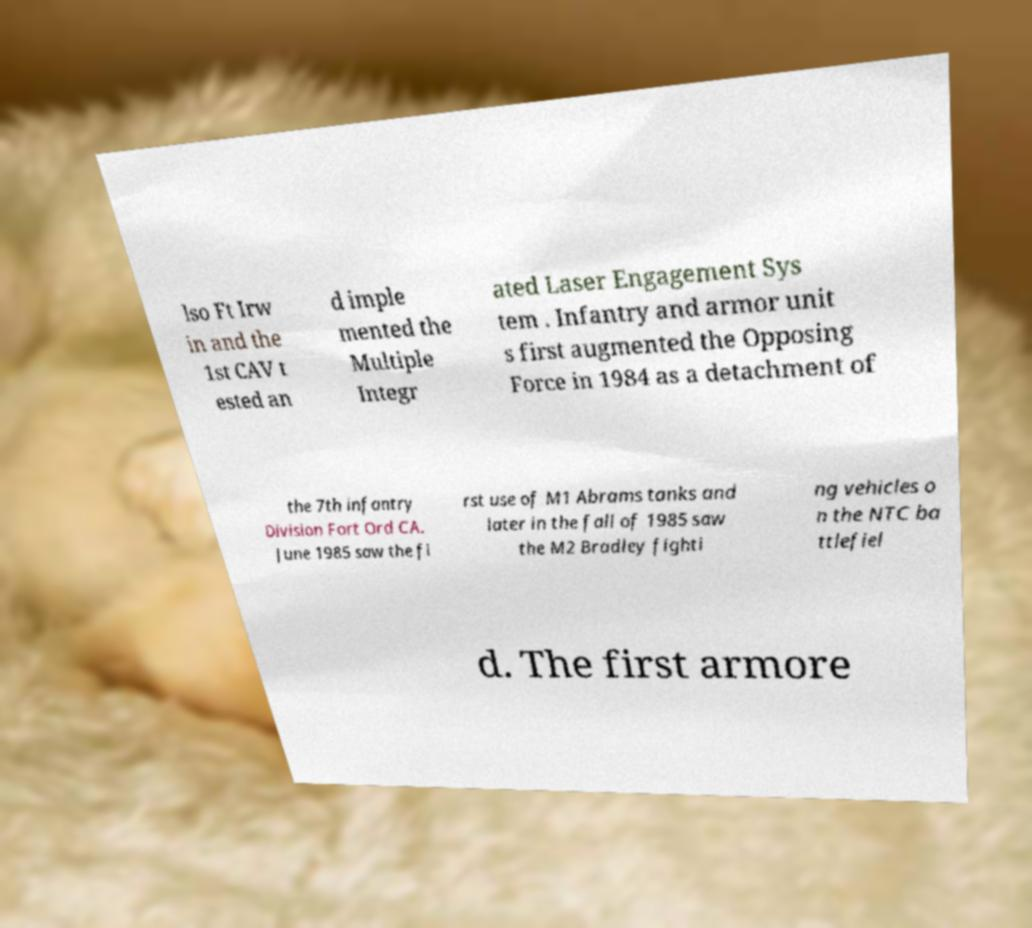Could you assist in decoding the text presented in this image and type it out clearly? lso Ft Irw in and the 1st CAV t ested an d imple mented the Multiple Integr ated Laser Engagement Sys tem . Infantry and armor unit s first augmented the Opposing Force in 1984 as a detachment of the 7th infantry Division Fort Ord CA. June 1985 saw the fi rst use of M1 Abrams tanks and later in the fall of 1985 saw the M2 Bradley fighti ng vehicles o n the NTC ba ttlefiel d. The first armore 